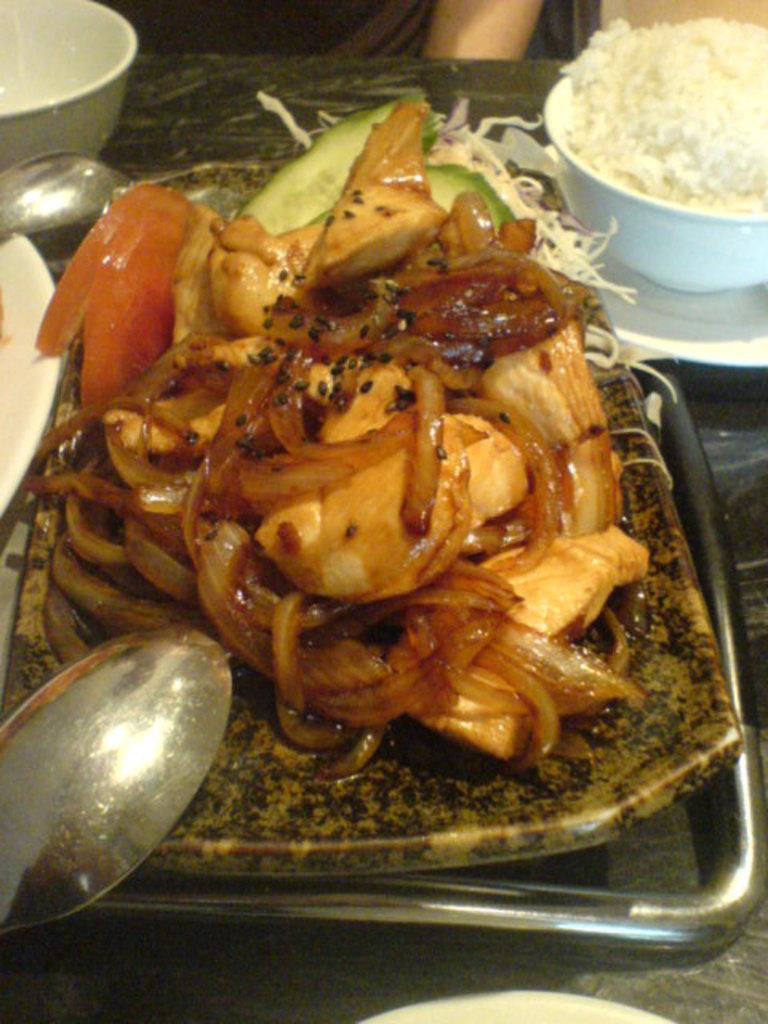How would you summarize this image in a sentence or two? There are food items arranged on a plate. Beside this place, there is a spoon. This plate is on a table, on which there is a white color cup having rice, another white color cup and a white color plate, on which there is a spoon. 